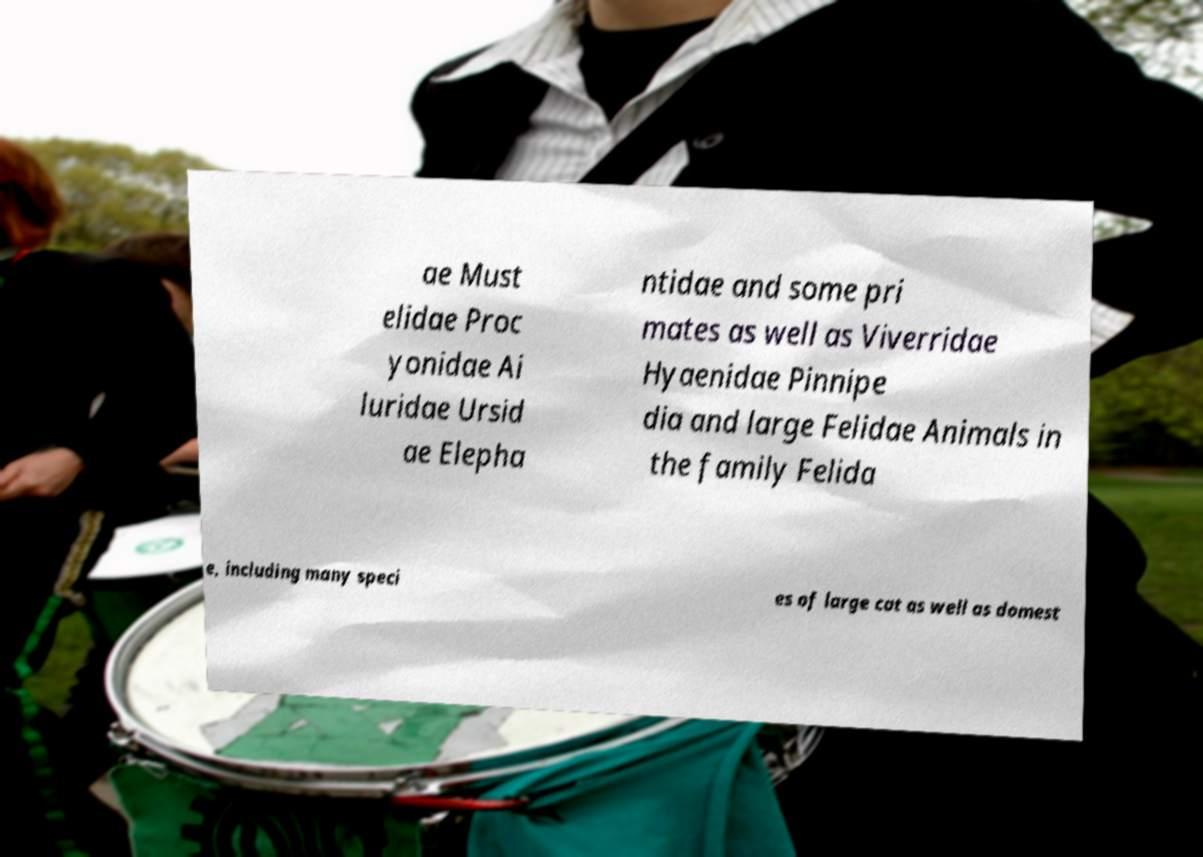Could you extract and type out the text from this image? ae Must elidae Proc yonidae Ai luridae Ursid ae Elepha ntidae and some pri mates as well as Viverridae Hyaenidae Pinnipe dia and large Felidae Animals in the family Felida e, including many speci es of large cat as well as domest 